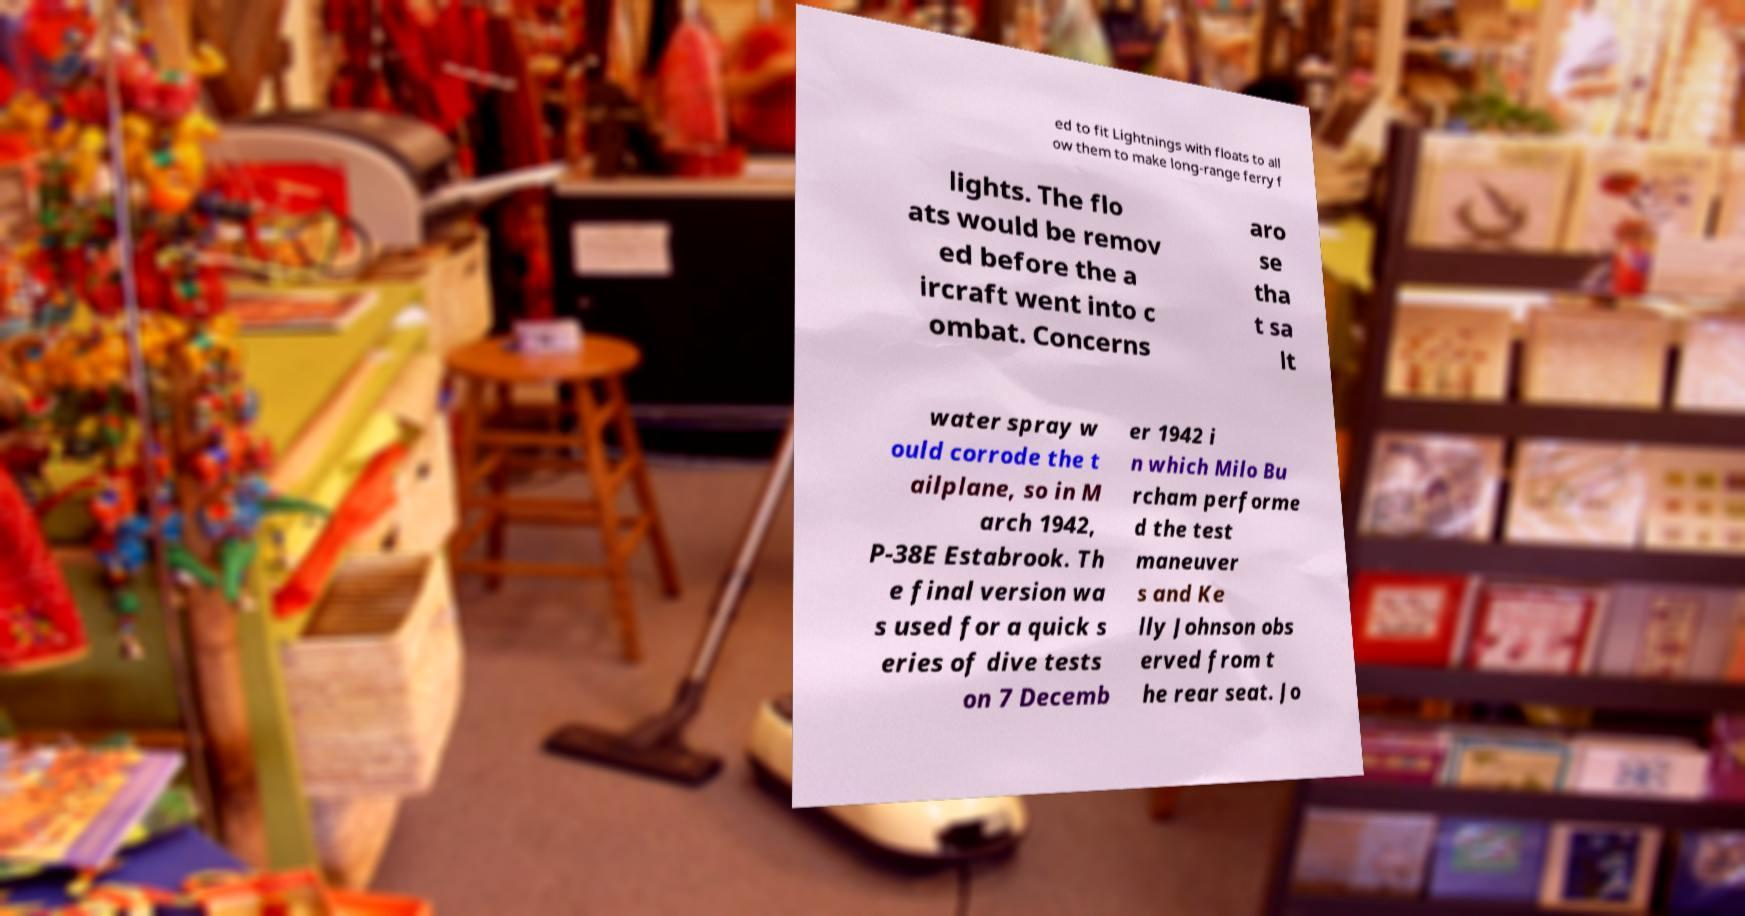I need the written content from this picture converted into text. Can you do that? ed to fit Lightnings with floats to all ow them to make long-range ferry f lights. The flo ats would be remov ed before the a ircraft went into c ombat. Concerns aro se tha t sa lt water spray w ould corrode the t ailplane, so in M arch 1942, P-38E Estabrook. Th e final version wa s used for a quick s eries of dive tests on 7 Decemb er 1942 i n which Milo Bu rcham performe d the test maneuver s and Ke lly Johnson obs erved from t he rear seat. Jo 